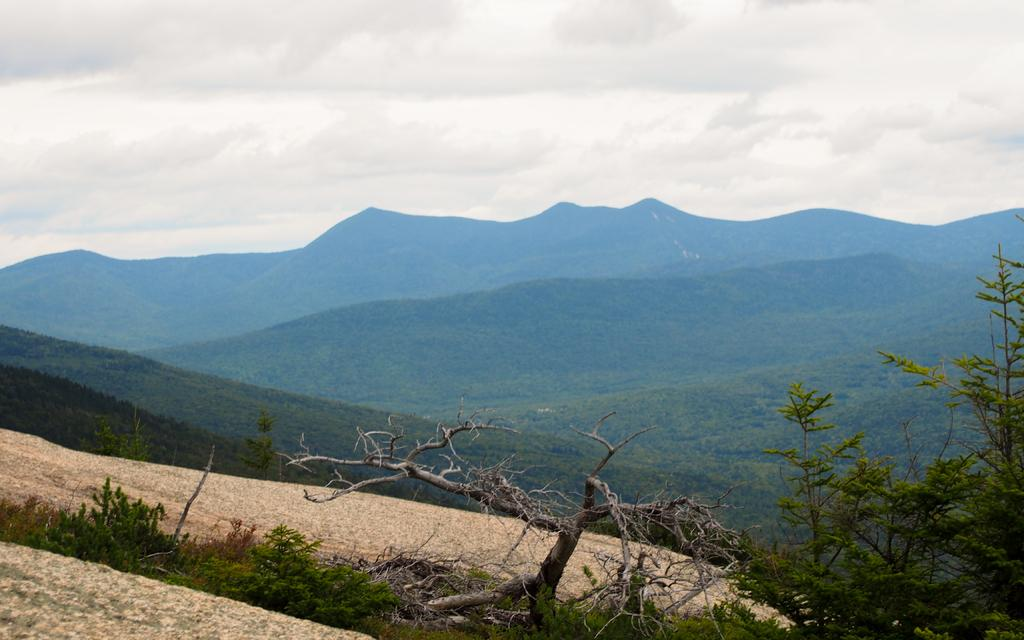What type of natural landscape is depicted in the image? The image features mountains and trees. Can you describe the mountains in the image? The mountains are visible in the background of the image. What type of vegetation is present in the image? There are trees in the image. How many cherries can be seen hanging from the trees in the image? There are no cherries visible in the image; it features mountains and trees. What type of animals can be seen interacting with the trees in the image? There are no animals present in the image; it features mountains and trees. 